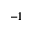Convert formula to latex. <formula><loc_0><loc_0><loc_500><loc_500>^ { - 1 }</formula> 